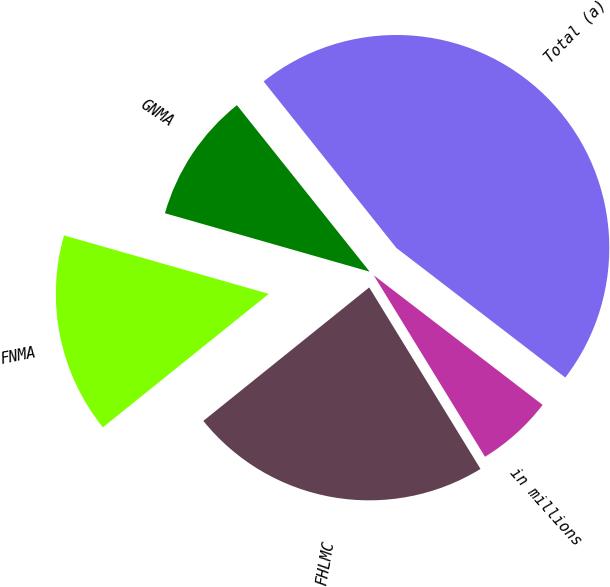<chart> <loc_0><loc_0><loc_500><loc_500><pie_chart><fcel>in millions<fcel>FHLMC<fcel>FNMA<fcel>GNMA<fcel>Total (a)<nl><fcel>5.83%<fcel>22.97%<fcel>15.21%<fcel>9.86%<fcel>46.13%<nl></chart> 